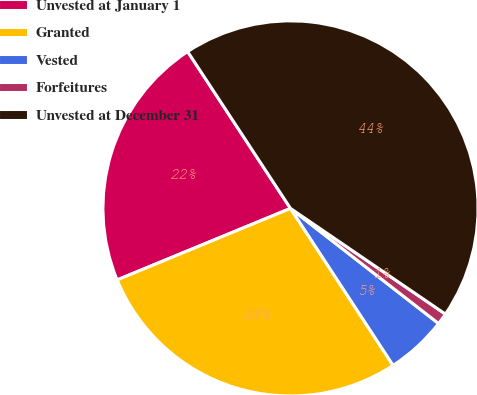Convert chart. <chart><loc_0><loc_0><loc_500><loc_500><pie_chart><fcel>Unvested at January 1<fcel>Granted<fcel>Vested<fcel>Forfeitures<fcel>Unvested at December 31<nl><fcel>21.99%<fcel>27.99%<fcel>5.27%<fcel>0.99%<fcel>43.77%<nl></chart> 